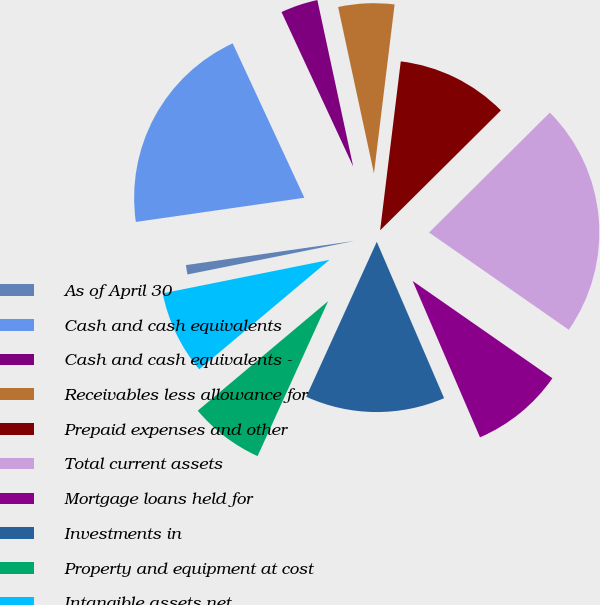<chart> <loc_0><loc_0><loc_500><loc_500><pie_chart><fcel>As of April 30<fcel>Cash and cash equivalents<fcel>Cash and cash equivalents -<fcel>Receivables less allowance for<fcel>Prepaid expenses and other<fcel>Total current assets<fcel>Mortgage loans held for<fcel>Investments in<fcel>Property and equipment at cost<fcel>Intangible assets net<nl><fcel>0.89%<fcel>20.35%<fcel>3.54%<fcel>5.31%<fcel>10.62%<fcel>22.12%<fcel>8.85%<fcel>13.27%<fcel>7.08%<fcel>7.96%<nl></chart> 